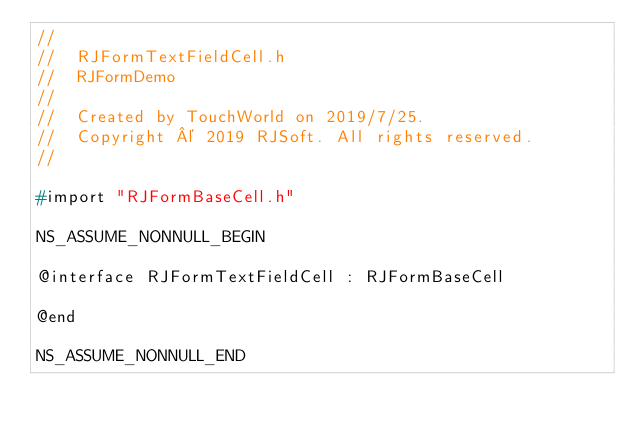<code> <loc_0><loc_0><loc_500><loc_500><_C_>//
//  RJFormTextFieldCell.h
//  RJFormDemo
//
//  Created by TouchWorld on 2019/7/25.
//  Copyright © 2019 RJSoft. All rights reserved.
//

#import "RJFormBaseCell.h"

NS_ASSUME_NONNULL_BEGIN

@interface RJFormTextFieldCell : RJFormBaseCell

@end

NS_ASSUME_NONNULL_END
</code> 